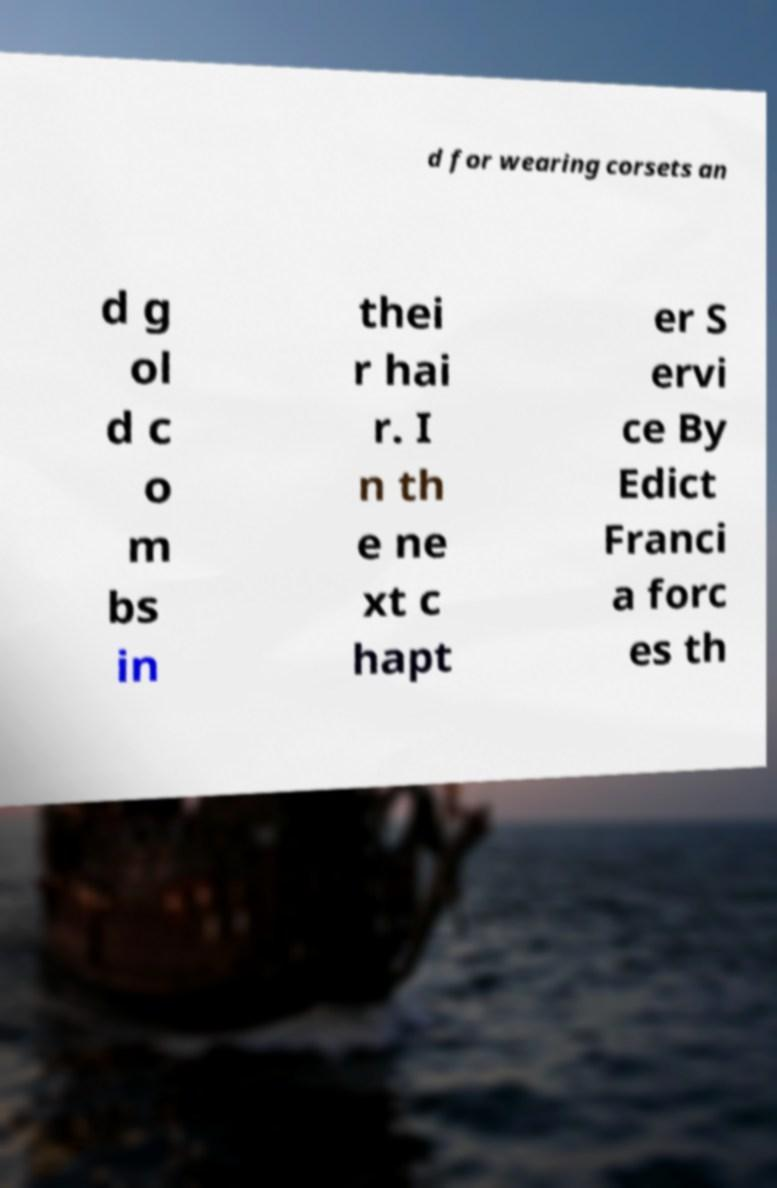What messages or text are displayed in this image? I need them in a readable, typed format. d for wearing corsets an d g ol d c o m bs in thei r hai r. I n th e ne xt c hapt er S ervi ce By Edict Franci a forc es th 